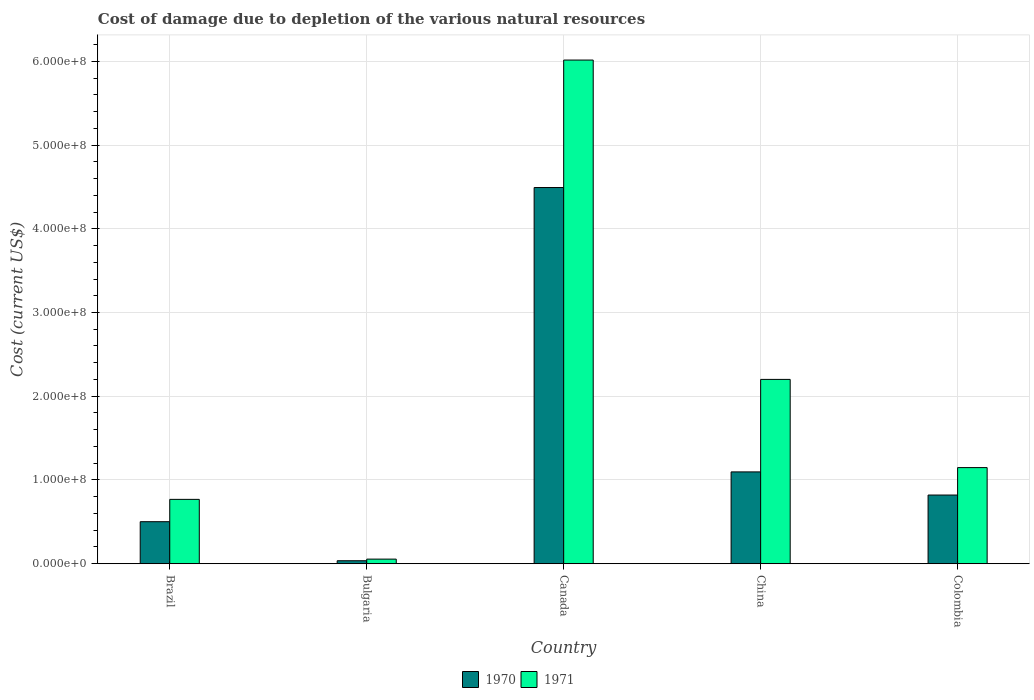How many different coloured bars are there?
Make the answer very short. 2. Are the number of bars on each tick of the X-axis equal?
Give a very brief answer. Yes. How many bars are there on the 3rd tick from the right?
Your answer should be compact. 2. In how many cases, is the number of bars for a given country not equal to the number of legend labels?
Your answer should be very brief. 0. What is the cost of damage caused due to the depletion of various natural resources in 1971 in Brazil?
Offer a very short reply. 7.69e+07. Across all countries, what is the maximum cost of damage caused due to the depletion of various natural resources in 1971?
Ensure brevity in your answer.  6.01e+08. Across all countries, what is the minimum cost of damage caused due to the depletion of various natural resources in 1970?
Your answer should be very brief. 3.56e+06. In which country was the cost of damage caused due to the depletion of various natural resources in 1971 maximum?
Your answer should be very brief. Canada. In which country was the cost of damage caused due to the depletion of various natural resources in 1970 minimum?
Offer a terse response. Bulgaria. What is the total cost of damage caused due to the depletion of various natural resources in 1971 in the graph?
Your answer should be compact. 1.02e+09. What is the difference between the cost of damage caused due to the depletion of various natural resources in 1970 in Canada and that in China?
Your answer should be very brief. 3.40e+08. What is the difference between the cost of damage caused due to the depletion of various natural resources in 1970 in Brazil and the cost of damage caused due to the depletion of various natural resources in 1971 in Colombia?
Your response must be concise. -6.46e+07. What is the average cost of damage caused due to the depletion of various natural resources in 1970 per country?
Provide a succinct answer. 1.39e+08. What is the difference between the cost of damage caused due to the depletion of various natural resources of/in 1970 and cost of damage caused due to the depletion of various natural resources of/in 1971 in China?
Provide a short and direct response. -1.10e+08. What is the ratio of the cost of damage caused due to the depletion of various natural resources in 1970 in Bulgaria to that in China?
Provide a short and direct response. 0.03. What is the difference between the highest and the second highest cost of damage caused due to the depletion of various natural resources in 1970?
Offer a terse response. -2.76e+07. What is the difference between the highest and the lowest cost of damage caused due to the depletion of various natural resources in 1971?
Offer a terse response. 5.96e+08. In how many countries, is the cost of damage caused due to the depletion of various natural resources in 1970 greater than the average cost of damage caused due to the depletion of various natural resources in 1970 taken over all countries?
Your response must be concise. 1. How many bars are there?
Your answer should be compact. 10. Are all the bars in the graph horizontal?
Offer a terse response. No. Does the graph contain any zero values?
Offer a very short reply. No. Does the graph contain grids?
Offer a terse response. Yes. Where does the legend appear in the graph?
Your answer should be compact. Bottom center. How are the legend labels stacked?
Keep it short and to the point. Horizontal. What is the title of the graph?
Keep it short and to the point. Cost of damage due to depletion of the various natural resources. What is the label or title of the X-axis?
Keep it short and to the point. Country. What is the label or title of the Y-axis?
Give a very brief answer. Cost (current US$). What is the Cost (current US$) in 1970 in Brazil?
Offer a terse response. 5.02e+07. What is the Cost (current US$) in 1971 in Brazil?
Provide a succinct answer. 7.69e+07. What is the Cost (current US$) of 1970 in Bulgaria?
Provide a succinct answer. 3.56e+06. What is the Cost (current US$) of 1971 in Bulgaria?
Your response must be concise. 5.51e+06. What is the Cost (current US$) in 1970 in Canada?
Make the answer very short. 4.49e+08. What is the Cost (current US$) of 1971 in Canada?
Your response must be concise. 6.01e+08. What is the Cost (current US$) of 1970 in China?
Keep it short and to the point. 1.10e+08. What is the Cost (current US$) of 1971 in China?
Ensure brevity in your answer.  2.20e+08. What is the Cost (current US$) in 1970 in Colombia?
Keep it short and to the point. 8.20e+07. What is the Cost (current US$) of 1971 in Colombia?
Offer a terse response. 1.15e+08. Across all countries, what is the maximum Cost (current US$) of 1970?
Provide a short and direct response. 4.49e+08. Across all countries, what is the maximum Cost (current US$) in 1971?
Your response must be concise. 6.01e+08. Across all countries, what is the minimum Cost (current US$) of 1970?
Your answer should be compact. 3.56e+06. Across all countries, what is the minimum Cost (current US$) in 1971?
Provide a short and direct response. 5.51e+06. What is the total Cost (current US$) in 1970 in the graph?
Your answer should be very brief. 6.95e+08. What is the total Cost (current US$) in 1971 in the graph?
Offer a terse response. 1.02e+09. What is the difference between the Cost (current US$) of 1970 in Brazil and that in Bulgaria?
Give a very brief answer. 4.66e+07. What is the difference between the Cost (current US$) of 1971 in Brazil and that in Bulgaria?
Provide a succinct answer. 7.14e+07. What is the difference between the Cost (current US$) in 1970 in Brazil and that in Canada?
Your response must be concise. -3.99e+08. What is the difference between the Cost (current US$) of 1971 in Brazil and that in Canada?
Provide a short and direct response. -5.25e+08. What is the difference between the Cost (current US$) of 1970 in Brazil and that in China?
Offer a very short reply. -5.95e+07. What is the difference between the Cost (current US$) of 1971 in Brazil and that in China?
Offer a terse response. -1.43e+08. What is the difference between the Cost (current US$) in 1970 in Brazil and that in Colombia?
Provide a short and direct response. -3.18e+07. What is the difference between the Cost (current US$) in 1971 in Brazil and that in Colombia?
Provide a succinct answer. -3.79e+07. What is the difference between the Cost (current US$) of 1970 in Bulgaria and that in Canada?
Keep it short and to the point. -4.46e+08. What is the difference between the Cost (current US$) of 1971 in Bulgaria and that in Canada?
Offer a very short reply. -5.96e+08. What is the difference between the Cost (current US$) in 1970 in Bulgaria and that in China?
Your answer should be compact. -1.06e+08. What is the difference between the Cost (current US$) of 1971 in Bulgaria and that in China?
Provide a short and direct response. -2.15e+08. What is the difference between the Cost (current US$) in 1970 in Bulgaria and that in Colombia?
Ensure brevity in your answer.  -7.85e+07. What is the difference between the Cost (current US$) of 1971 in Bulgaria and that in Colombia?
Ensure brevity in your answer.  -1.09e+08. What is the difference between the Cost (current US$) of 1970 in Canada and that in China?
Make the answer very short. 3.40e+08. What is the difference between the Cost (current US$) in 1971 in Canada and that in China?
Offer a very short reply. 3.81e+08. What is the difference between the Cost (current US$) in 1970 in Canada and that in Colombia?
Your answer should be very brief. 3.67e+08. What is the difference between the Cost (current US$) of 1971 in Canada and that in Colombia?
Give a very brief answer. 4.87e+08. What is the difference between the Cost (current US$) in 1970 in China and that in Colombia?
Offer a very short reply. 2.76e+07. What is the difference between the Cost (current US$) in 1971 in China and that in Colombia?
Your answer should be compact. 1.05e+08. What is the difference between the Cost (current US$) in 1970 in Brazil and the Cost (current US$) in 1971 in Bulgaria?
Make the answer very short. 4.47e+07. What is the difference between the Cost (current US$) of 1970 in Brazil and the Cost (current US$) of 1971 in Canada?
Offer a very short reply. -5.51e+08. What is the difference between the Cost (current US$) of 1970 in Brazil and the Cost (current US$) of 1971 in China?
Ensure brevity in your answer.  -1.70e+08. What is the difference between the Cost (current US$) in 1970 in Brazil and the Cost (current US$) in 1971 in Colombia?
Ensure brevity in your answer.  -6.46e+07. What is the difference between the Cost (current US$) of 1970 in Bulgaria and the Cost (current US$) of 1971 in Canada?
Your answer should be compact. -5.98e+08. What is the difference between the Cost (current US$) in 1970 in Bulgaria and the Cost (current US$) in 1971 in China?
Provide a succinct answer. -2.17e+08. What is the difference between the Cost (current US$) in 1970 in Bulgaria and the Cost (current US$) in 1971 in Colombia?
Give a very brief answer. -1.11e+08. What is the difference between the Cost (current US$) of 1970 in Canada and the Cost (current US$) of 1971 in China?
Provide a succinct answer. 2.29e+08. What is the difference between the Cost (current US$) of 1970 in Canada and the Cost (current US$) of 1971 in Colombia?
Provide a succinct answer. 3.34e+08. What is the difference between the Cost (current US$) of 1970 in China and the Cost (current US$) of 1971 in Colombia?
Your answer should be very brief. -5.13e+06. What is the average Cost (current US$) of 1970 per country?
Your answer should be very brief. 1.39e+08. What is the average Cost (current US$) in 1971 per country?
Provide a short and direct response. 2.04e+08. What is the difference between the Cost (current US$) of 1970 and Cost (current US$) of 1971 in Brazil?
Your response must be concise. -2.67e+07. What is the difference between the Cost (current US$) in 1970 and Cost (current US$) in 1971 in Bulgaria?
Provide a short and direct response. -1.95e+06. What is the difference between the Cost (current US$) of 1970 and Cost (current US$) of 1971 in Canada?
Your response must be concise. -1.52e+08. What is the difference between the Cost (current US$) of 1970 and Cost (current US$) of 1971 in China?
Your response must be concise. -1.10e+08. What is the difference between the Cost (current US$) of 1970 and Cost (current US$) of 1971 in Colombia?
Provide a succinct answer. -3.28e+07. What is the ratio of the Cost (current US$) of 1970 in Brazil to that in Bulgaria?
Offer a terse response. 14.09. What is the ratio of the Cost (current US$) in 1971 in Brazil to that in Bulgaria?
Provide a succinct answer. 13.95. What is the ratio of the Cost (current US$) of 1970 in Brazil to that in Canada?
Your response must be concise. 0.11. What is the ratio of the Cost (current US$) of 1971 in Brazil to that in Canada?
Ensure brevity in your answer.  0.13. What is the ratio of the Cost (current US$) of 1970 in Brazil to that in China?
Your answer should be very brief. 0.46. What is the ratio of the Cost (current US$) of 1971 in Brazil to that in China?
Your answer should be compact. 0.35. What is the ratio of the Cost (current US$) of 1970 in Brazil to that in Colombia?
Provide a short and direct response. 0.61. What is the ratio of the Cost (current US$) in 1971 in Brazil to that in Colombia?
Provide a short and direct response. 0.67. What is the ratio of the Cost (current US$) in 1970 in Bulgaria to that in Canada?
Make the answer very short. 0.01. What is the ratio of the Cost (current US$) of 1971 in Bulgaria to that in Canada?
Keep it short and to the point. 0.01. What is the ratio of the Cost (current US$) of 1970 in Bulgaria to that in China?
Offer a terse response. 0.03. What is the ratio of the Cost (current US$) of 1971 in Bulgaria to that in China?
Make the answer very short. 0.03. What is the ratio of the Cost (current US$) of 1970 in Bulgaria to that in Colombia?
Your answer should be very brief. 0.04. What is the ratio of the Cost (current US$) of 1971 in Bulgaria to that in Colombia?
Offer a terse response. 0.05. What is the ratio of the Cost (current US$) of 1970 in Canada to that in China?
Offer a very short reply. 4.1. What is the ratio of the Cost (current US$) of 1971 in Canada to that in China?
Provide a succinct answer. 2.73. What is the ratio of the Cost (current US$) in 1970 in Canada to that in Colombia?
Offer a very short reply. 5.48. What is the ratio of the Cost (current US$) of 1971 in Canada to that in Colombia?
Your answer should be very brief. 5.24. What is the ratio of the Cost (current US$) in 1970 in China to that in Colombia?
Offer a very short reply. 1.34. What is the ratio of the Cost (current US$) in 1971 in China to that in Colombia?
Ensure brevity in your answer.  1.92. What is the difference between the highest and the second highest Cost (current US$) in 1970?
Your answer should be compact. 3.40e+08. What is the difference between the highest and the second highest Cost (current US$) of 1971?
Your answer should be very brief. 3.81e+08. What is the difference between the highest and the lowest Cost (current US$) of 1970?
Your answer should be compact. 4.46e+08. What is the difference between the highest and the lowest Cost (current US$) of 1971?
Provide a short and direct response. 5.96e+08. 